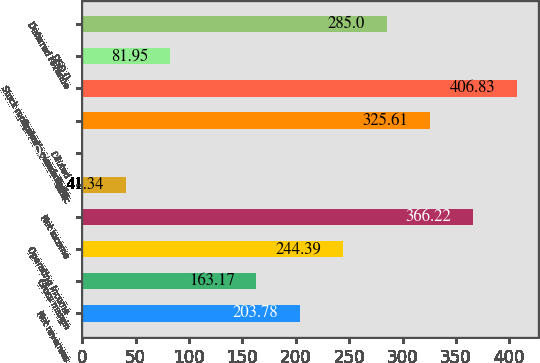<chart> <loc_0><loc_0><loc_500><loc_500><bar_chart><fcel>Net revenues<fcel>Gross margin<fcel>Operating income<fcel>Net income<fcel>Basic<fcel>Diluted<fcel>Operating cash flows<fcel>Stock repurchase plan activity<fcel>DSO ()<fcel>Deferred revenue<nl><fcel>203.78<fcel>163.17<fcel>244.39<fcel>366.22<fcel>41.34<fcel>0.73<fcel>325.61<fcel>406.83<fcel>81.95<fcel>285<nl></chart> 